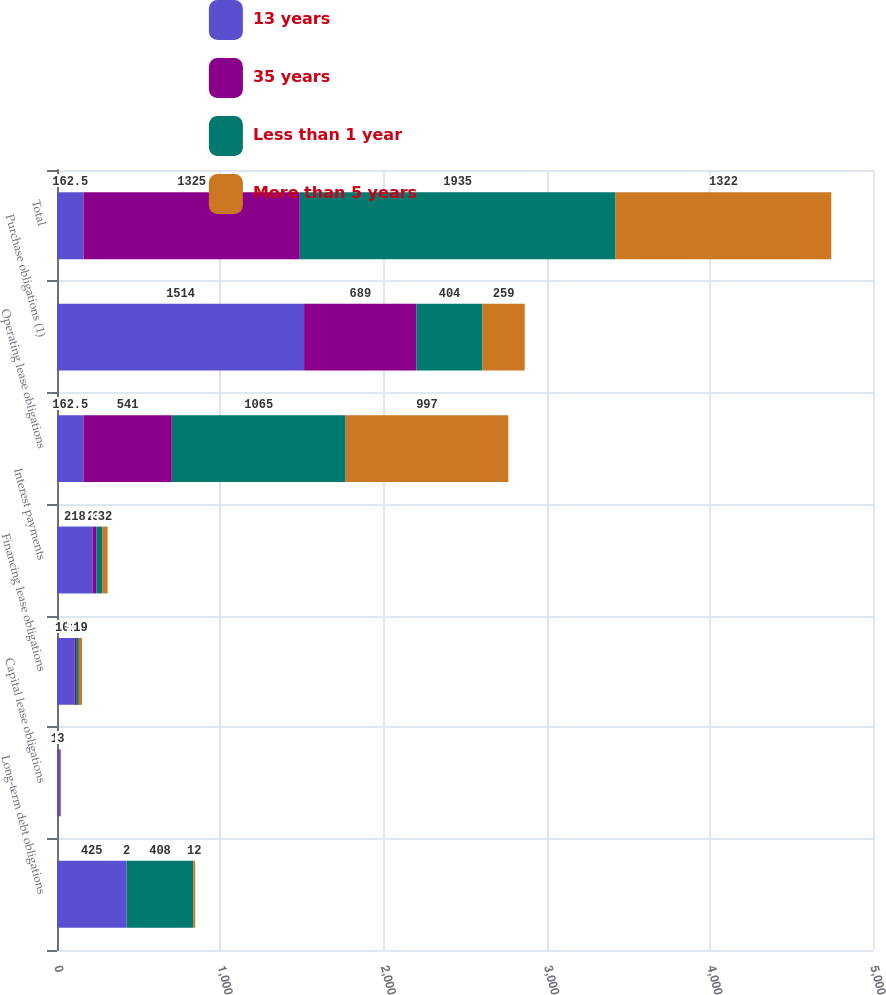Convert chart. <chart><loc_0><loc_0><loc_500><loc_500><stacked_bar_chart><ecel><fcel>Long-term debt obligations<fcel>Capital lease obligations<fcel>Financing lease obligations<fcel>Interest payments<fcel>Operating lease obligations<fcel>Purchase obligations (1)<fcel>Total<nl><fcel>13 years<fcel>425<fcel>13<fcel>107<fcel>218<fcel>162.5<fcel>1514<fcel>162.5<nl><fcel>35 years<fcel>2<fcel>5<fcel>10<fcel>23<fcel>541<fcel>689<fcel>1325<nl><fcel>Less than 1 year<fcel>408<fcel>4<fcel>17<fcel>37<fcel>1065<fcel>404<fcel>1935<nl><fcel>More than 5 years<fcel>12<fcel>3<fcel>19<fcel>32<fcel>997<fcel>259<fcel>1322<nl></chart> 